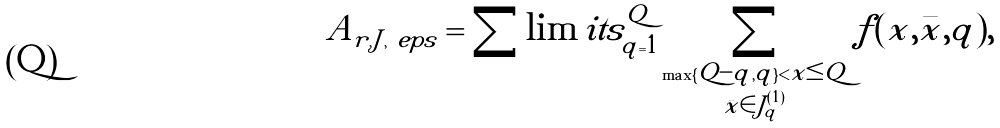<formula> <loc_0><loc_0><loc_500><loc_500>A _ { r , J , \ e p s } = \sum \lim i t s _ { q = 1 } ^ { Q } \sum _ { \substack { \max \{ Q - q , q \} < x \leq Q \\ \bar { x } \in J _ { q } ^ { ( 1 ) } } } f ( x , \bar { x } , q ) ,</formula> 